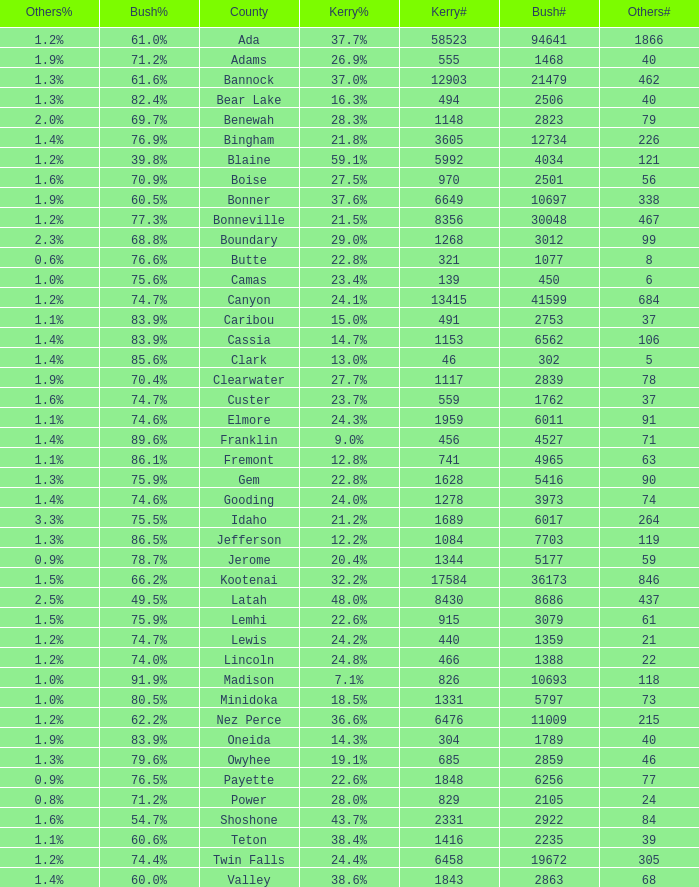What percentage of the people in Bonneville voted for Bush? 77.3%. 